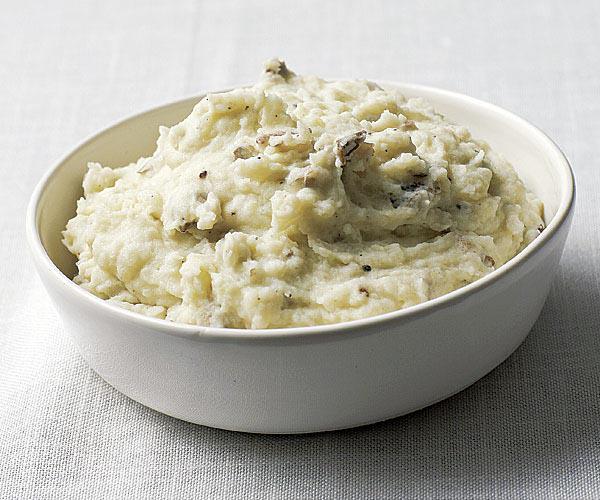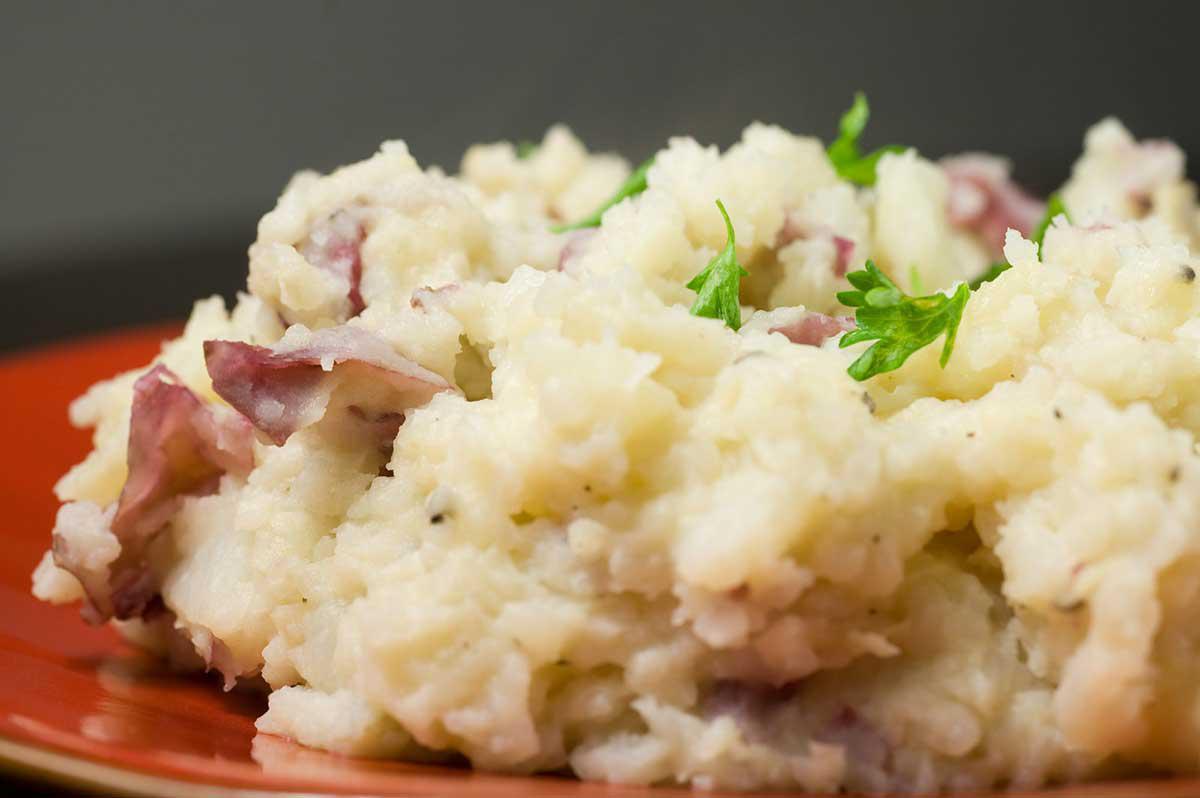The first image is the image on the left, the second image is the image on the right. Examine the images to the left and right. Is the description "There is one spoon sitting next to a bowl of food." accurate? Answer yes or no. No. The first image is the image on the left, the second image is the image on the right. For the images displayed, is the sentence "an eating utensil can be seen in the image on the right" factually correct? Answer yes or no. No. 